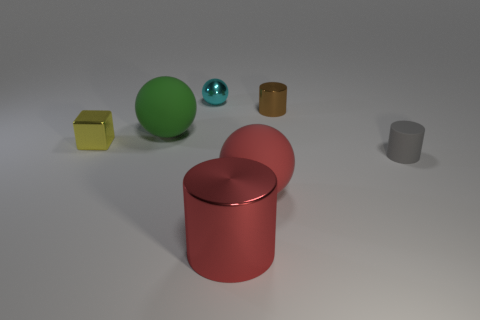Subtract 1 cylinders. How many cylinders are left? 2 Subtract all gray cylinders. How many cylinders are left? 2 Subtract all shiny cylinders. How many cylinders are left? 1 Add 2 cyan balls. How many cyan balls are left? 3 Add 7 red shiny things. How many red shiny things exist? 8 Add 3 brown things. How many objects exist? 10 Subtract 1 yellow cubes. How many objects are left? 6 Subtract all balls. How many objects are left? 4 Subtract all gray spheres. Subtract all gray cubes. How many spheres are left? 3 Subtract all red spheres. How many brown cylinders are left? 1 